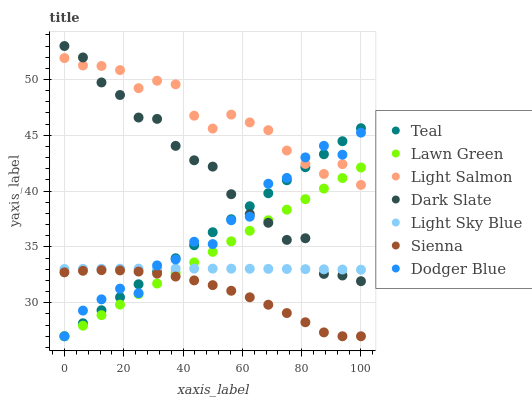Does Sienna have the minimum area under the curve?
Answer yes or no. Yes. Does Light Salmon have the maximum area under the curve?
Answer yes or no. Yes. Does Light Salmon have the minimum area under the curve?
Answer yes or no. No. Does Sienna have the maximum area under the curve?
Answer yes or no. No. Is Teal the smoothest?
Answer yes or no. Yes. Is Dodger Blue the roughest?
Answer yes or no. Yes. Is Light Salmon the smoothest?
Answer yes or no. No. Is Light Salmon the roughest?
Answer yes or no. No. Does Lawn Green have the lowest value?
Answer yes or no. Yes. Does Light Salmon have the lowest value?
Answer yes or no. No. Does Dark Slate have the highest value?
Answer yes or no. Yes. Does Light Salmon have the highest value?
Answer yes or no. No. Is Light Sky Blue less than Light Salmon?
Answer yes or no. Yes. Is Dark Slate greater than Sienna?
Answer yes or no. Yes. Does Dark Slate intersect Light Salmon?
Answer yes or no. Yes. Is Dark Slate less than Light Salmon?
Answer yes or no. No. Is Dark Slate greater than Light Salmon?
Answer yes or no. No. Does Light Sky Blue intersect Light Salmon?
Answer yes or no. No. 